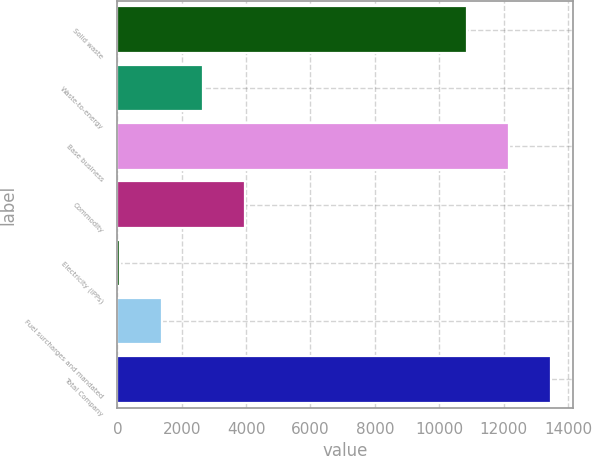Convert chart to OTSL. <chart><loc_0><loc_0><loc_500><loc_500><bar_chart><fcel>Solid waste<fcel>Waste-to-energy<fcel>Base business<fcel>Commodity<fcel>Electricity (IPPs)<fcel>Fuel surcharges and mandated<fcel>Total Company<nl><fcel>10877<fcel>2668.6<fcel>12173.8<fcel>3965.4<fcel>75<fcel>1371.8<fcel>13470.6<nl></chart> 